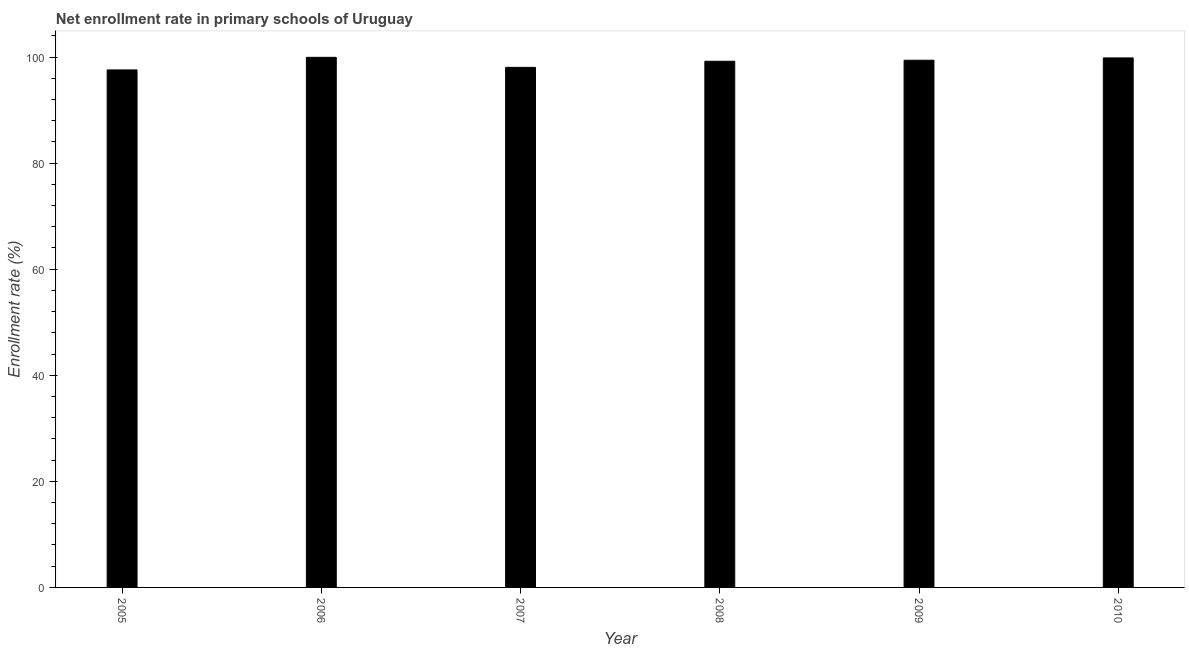What is the title of the graph?
Provide a succinct answer. Net enrollment rate in primary schools of Uruguay. What is the label or title of the Y-axis?
Ensure brevity in your answer.  Enrollment rate (%). What is the net enrollment rate in primary schools in 2010?
Offer a very short reply. 99.84. Across all years, what is the maximum net enrollment rate in primary schools?
Give a very brief answer. 99.95. Across all years, what is the minimum net enrollment rate in primary schools?
Provide a succinct answer. 97.58. In which year was the net enrollment rate in primary schools maximum?
Offer a terse response. 2006. What is the sum of the net enrollment rate in primary schools?
Ensure brevity in your answer.  594.03. What is the difference between the net enrollment rate in primary schools in 2006 and 2010?
Offer a terse response. 0.11. What is the average net enrollment rate in primary schools per year?
Keep it short and to the point. 99. What is the median net enrollment rate in primary schools?
Make the answer very short. 99.3. Do a majority of the years between 2009 and 2010 (inclusive) have net enrollment rate in primary schools greater than 4 %?
Give a very brief answer. Yes. Is the net enrollment rate in primary schools in 2006 less than that in 2008?
Your response must be concise. No. What is the difference between the highest and the second highest net enrollment rate in primary schools?
Provide a succinct answer. 0.11. What is the difference between the highest and the lowest net enrollment rate in primary schools?
Give a very brief answer. 2.37. Are all the bars in the graph horizontal?
Keep it short and to the point. No. Are the values on the major ticks of Y-axis written in scientific E-notation?
Ensure brevity in your answer.  No. What is the Enrollment rate (%) in 2005?
Your response must be concise. 97.58. What is the Enrollment rate (%) in 2006?
Offer a very short reply. 99.95. What is the Enrollment rate (%) in 2007?
Provide a succinct answer. 98.06. What is the Enrollment rate (%) of 2008?
Make the answer very short. 99.21. What is the Enrollment rate (%) of 2009?
Provide a short and direct response. 99.4. What is the Enrollment rate (%) in 2010?
Keep it short and to the point. 99.84. What is the difference between the Enrollment rate (%) in 2005 and 2006?
Ensure brevity in your answer.  -2.37. What is the difference between the Enrollment rate (%) in 2005 and 2007?
Your answer should be compact. -0.48. What is the difference between the Enrollment rate (%) in 2005 and 2008?
Your response must be concise. -1.63. What is the difference between the Enrollment rate (%) in 2005 and 2009?
Provide a succinct answer. -1.82. What is the difference between the Enrollment rate (%) in 2005 and 2010?
Give a very brief answer. -2.26. What is the difference between the Enrollment rate (%) in 2006 and 2007?
Give a very brief answer. 1.89. What is the difference between the Enrollment rate (%) in 2006 and 2008?
Provide a succinct answer. 0.74. What is the difference between the Enrollment rate (%) in 2006 and 2009?
Keep it short and to the point. 0.55. What is the difference between the Enrollment rate (%) in 2006 and 2010?
Your answer should be compact. 0.11. What is the difference between the Enrollment rate (%) in 2007 and 2008?
Your response must be concise. -1.15. What is the difference between the Enrollment rate (%) in 2007 and 2009?
Provide a succinct answer. -1.34. What is the difference between the Enrollment rate (%) in 2007 and 2010?
Keep it short and to the point. -1.78. What is the difference between the Enrollment rate (%) in 2008 and 2009?
Offer a terse response. -0.19. What is the difference between the Enrollment rate (%) in 2008 and 2010?
Ensure brevity in your answer.  -0.63. What is the difference between the Enrollment rate (%) in 2009 and 2010?
Offer a terse response. -0.44. What is the ratio of the Enrollment rate (%) in 2005 to that in 2006?
Your answer should be compact. 0.98. What is the ratio of the Enrollment rate (%) in 2005 to that in 2008?
Your answer should be very brief. 0.98. What is the ratio of the Enrollment rate (%) in 2005 to that in 2009?
Make the answer very short. 0.98. What is the ratio of the Enrollment rate (%) in 2006 to that in 2008?
Offer a terse response. 1.01. What is the ratio of the Enrollment rate (%) in 2006 to that in 2009?
Give a very brief answer. 1.01. What is the ratio of the Enrollment rate (%) in 2007 to that in 2008?
Provide a succinct answer. 0.99. What is the ratio of the Enrollment rate (%) in 2007 to that in 2009?
Provide a short and direct response. 0.99. What is the ratio of the Enrollment rate (%) in 2007 to that in 2010?
Your answer should be very brief. 0.98. 